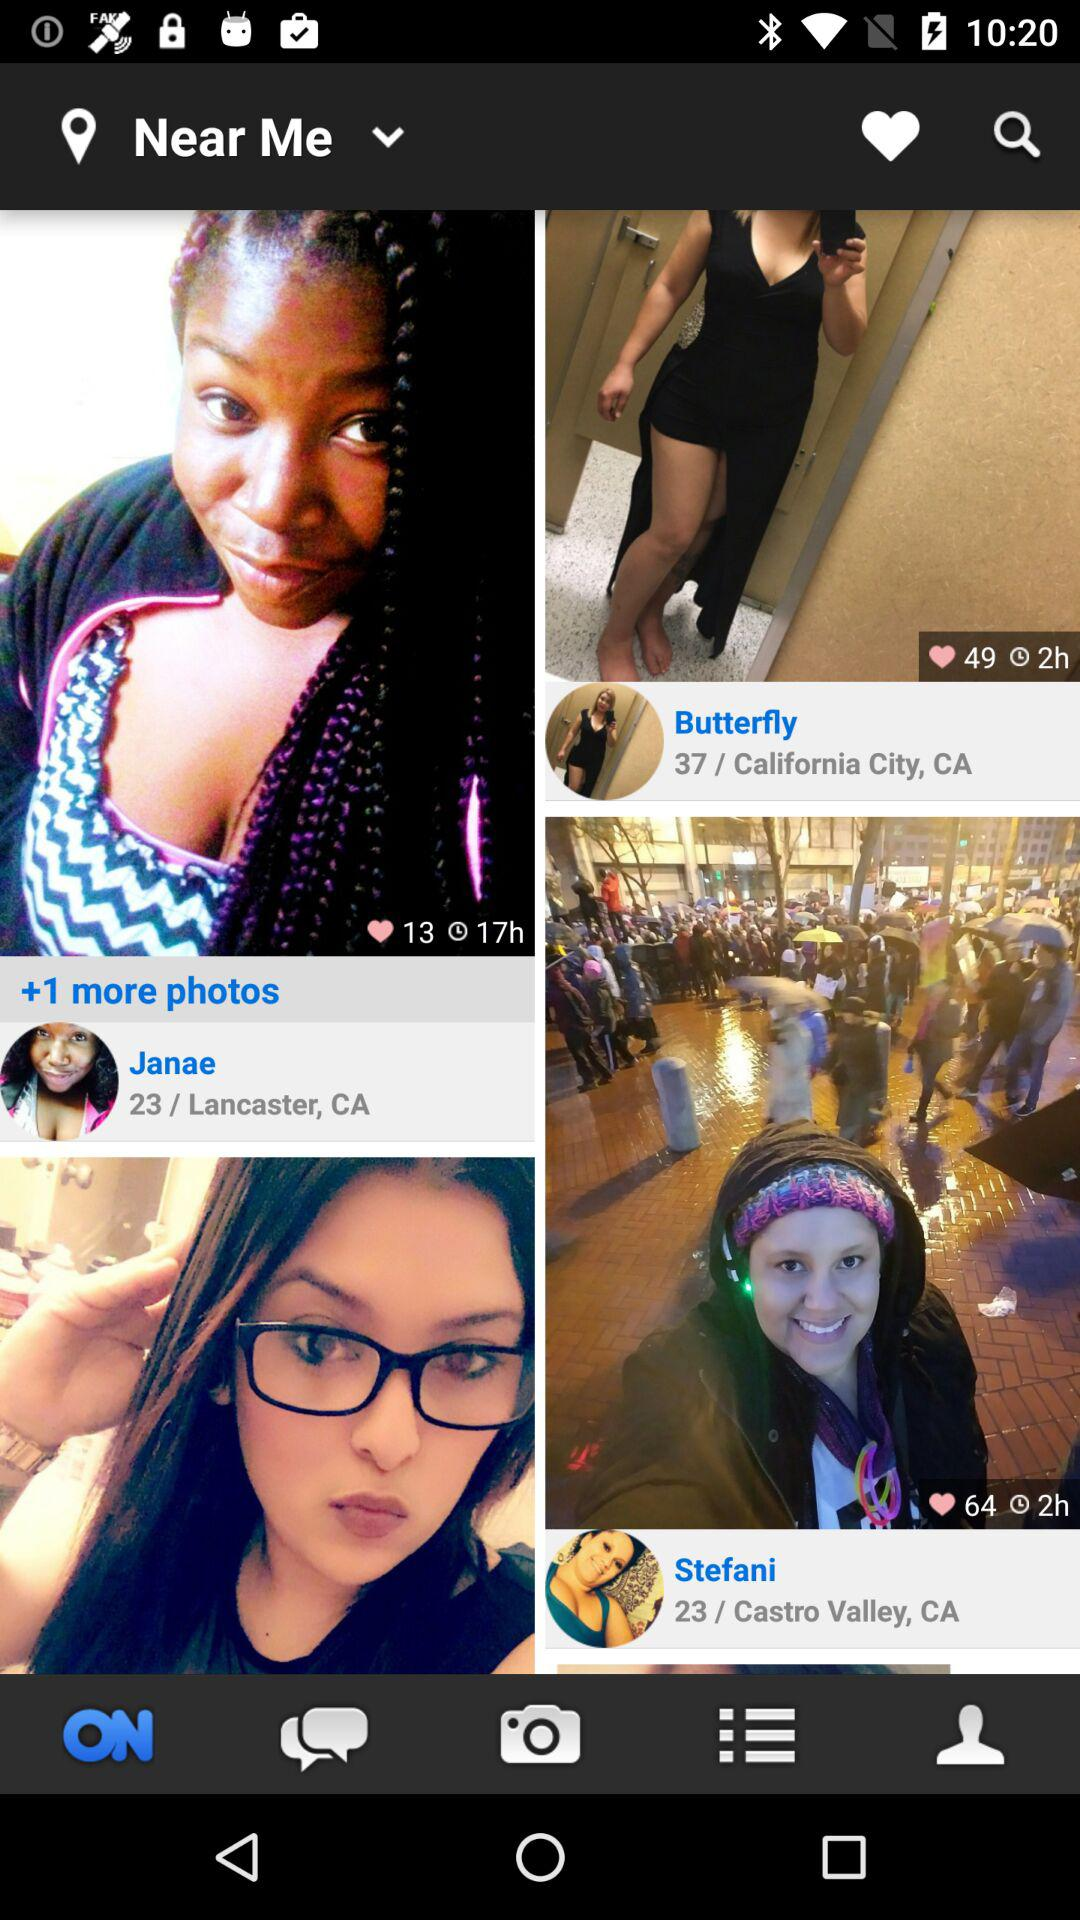What is the age of Stefani? Stefani's age is 23 years. 